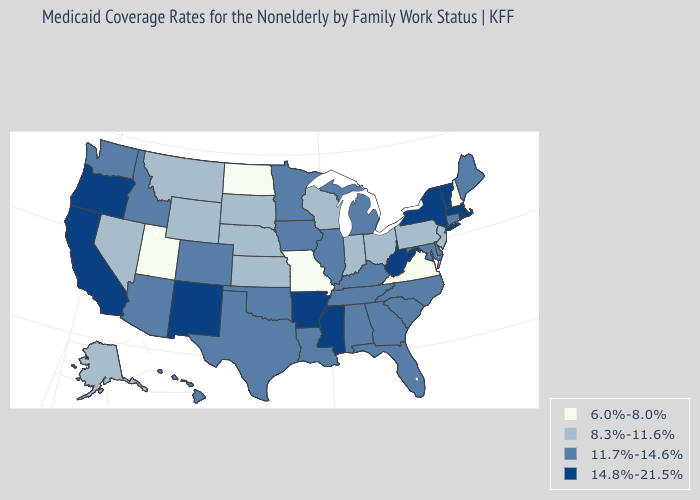Does Arkansas have a higher value than New Mexico?
Answer briefly. No. What is the lowest value in the MidWest?
Write a very short answer. 6.0%-8.0%. Does Utah have the highest value in the West?
Quick response, please. No. What is the value of Alabama?
Quick response, please. 11.7%-14.6%. What is the value of Wyoming?
Keep it brief. 8.3%-11.6%. Which states have the highest value in the USA?
Short answer required. Arkansas, California, Massachusetts, Mississippi, New Mexico, New York, Oregon, Rhode Island, Vermont, West Virginia. Name the states that have a value in the range 14.8%-21.5%?
Short answer required. Arkansas, California, Massachusetts, Mississippi, New Mexico, New York, Oregon, Rhode Island, Vermont, West Virginia. Does the map have missing data?
Give a very brief answer. No. Does Utah have the lowest value in the West?
Be succinct. Yes. Which states have the lowest value in the USA?
Concise answer only. Missouri, New Hampshire, North Dakota, Utah, Virginia. Does Wisconsin have the same value as Pennsylvania?
Concise answer only. Yes. What is the value of Texas?
Quick response, please. 11.7%-14.6%. What is the value of Wyoming?
Keep it brief. 8.3%-11.6%. Does Virginia have the lowest value in the South?
Answer briefly. Yes. 